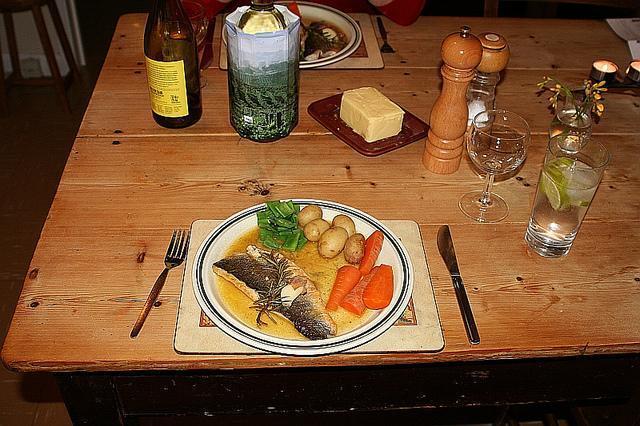How many carrots are there?
Give a very brief answer. 1. How many woman are holding a donut with one hand?
Give a very brief answer. 0. 